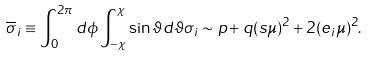Convert formula to latex. <formula><loc_0><loc_0><loc_500><loc_500>\overline { \sigma } _ { i } \equiv \int _ { 0 } ^ { 2 \pi } d \phi \int _ { - \chi } ^ { \chi } \sin \vartheta d \vartheta \sigma _ { i } \sim p + q ( s \mu ) ^ { 2 } + 2 ( e _ { i } \mu ) ^ { 2 } .</formula> 